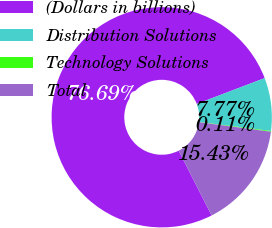<chart> <loc_0><loc_0><loc_500><loc_500><pie_chart><fcel>(Dollars in billions)<fcel>Distribution Solutions<fcel>Technology Solutions<fcel>Total<nl><fcel>76.69%<fcel>7.77%<fcel>0.11%<fcel>15.43%<nl></chart> 